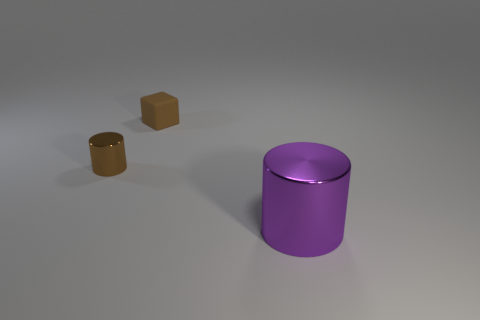Add 2 blue matte spheres. How many objects exist? 5 Subtract all cylinders. How many objects are left? 1 Add 3 large purple rubber cylinders. How many large purple rubber cylinders exist? 3 Subtract 0 red spheres. How many objects are left? 3 Subtract all big blue metal cylinders. Subtract all tiny rubber cubes. How many objects are left? 2 Add 1 small brown blocks. How many small brown blocks are left? 2 